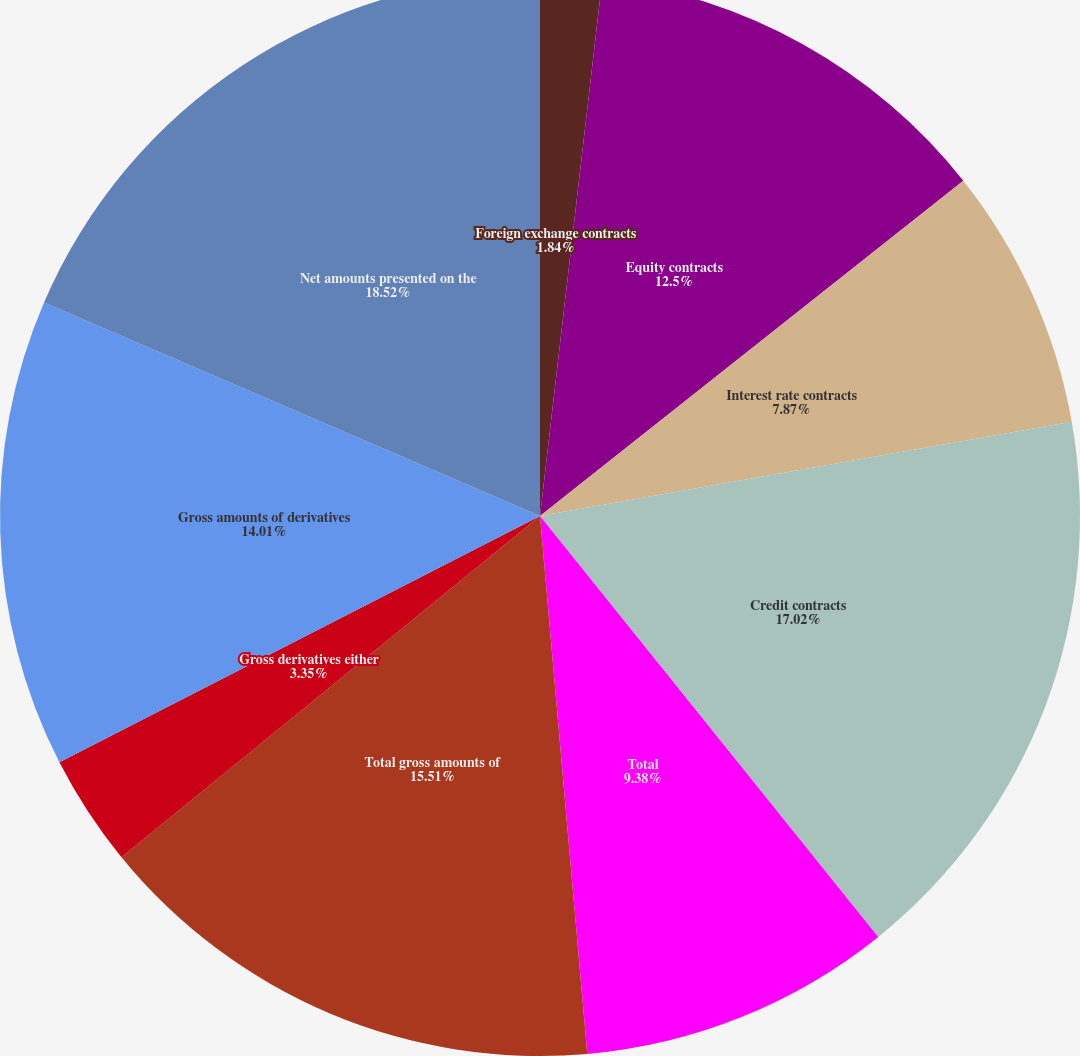Convert chart. <chart><loc_0><loc_0><loc_500><loc_500><pie_chart><fcel>Foreign exchange contracts<fcel>Equity contracts<fcel>Interest rate contracts<fcel>Credit contracts<fcel>Total<fcel>Total gross amounts of<fcel>Gross derivatives either<fcel>Gross amounts of derivatives<fcel>Net amounts presented on the<nl><fcel>1.84%<fcel>12.5%<fcel>7.87%<fcel>17.02%<fcel>9.38%<fcel>15.51%<fcel>3.35%<fcel>14.01%<fcel>18.53%<nl></chart> 